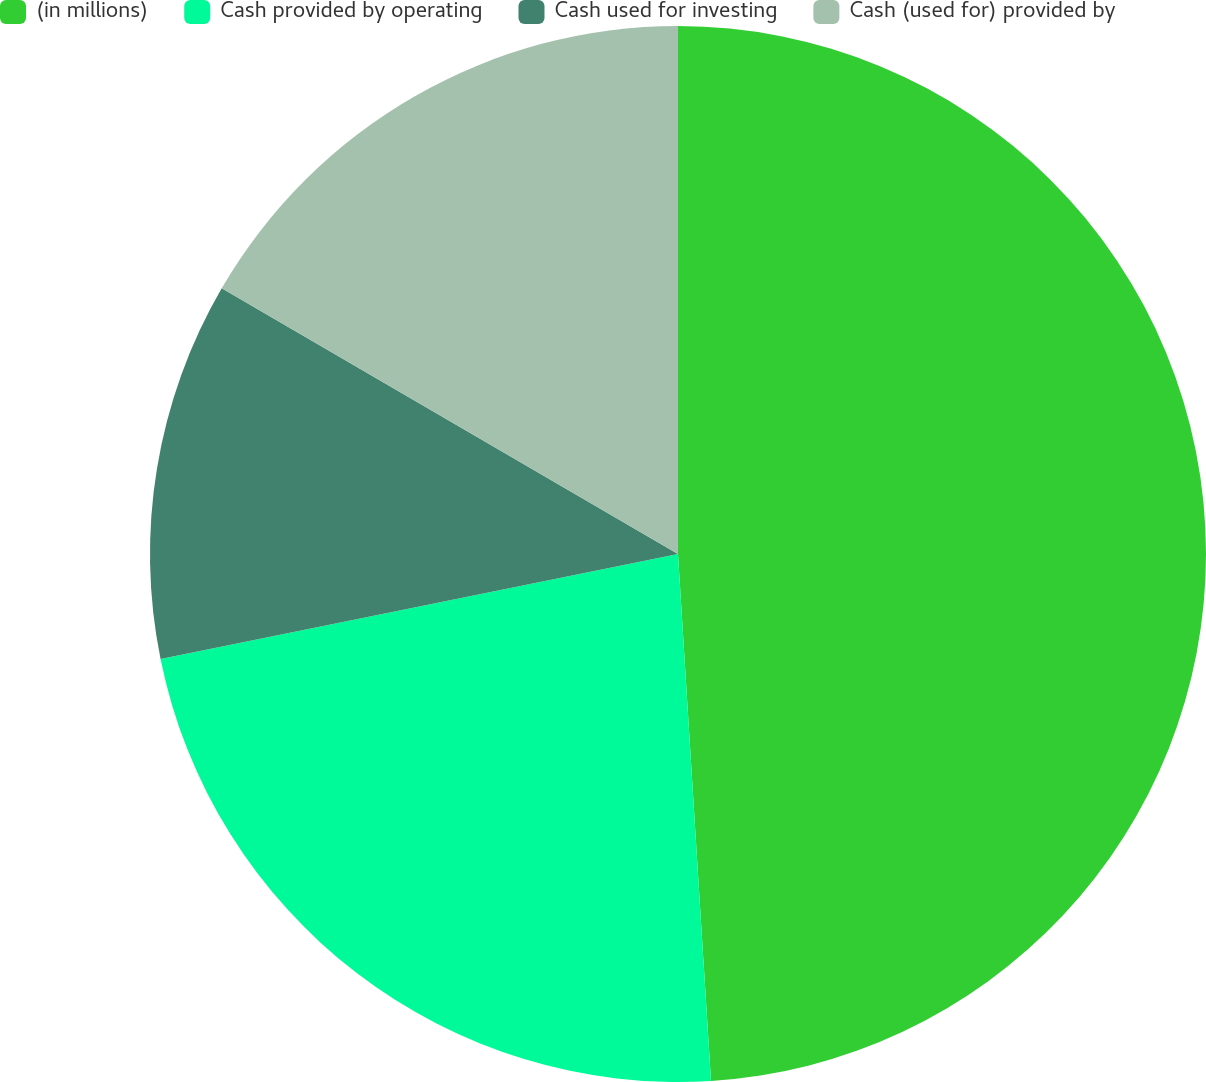Convert chart to OTSL. <chart><loc_0><loc_0><loc_500><loc_500><pie_chart><fcel>(in millions)<fcel>Cash provided by operating<fcel>Cash used for investing<fcel>Cash (used for) provided by<nl><fcel>49.01%<fcel>22.81%<fcel>11.58%<fcel>16.61%<nl></chart> 